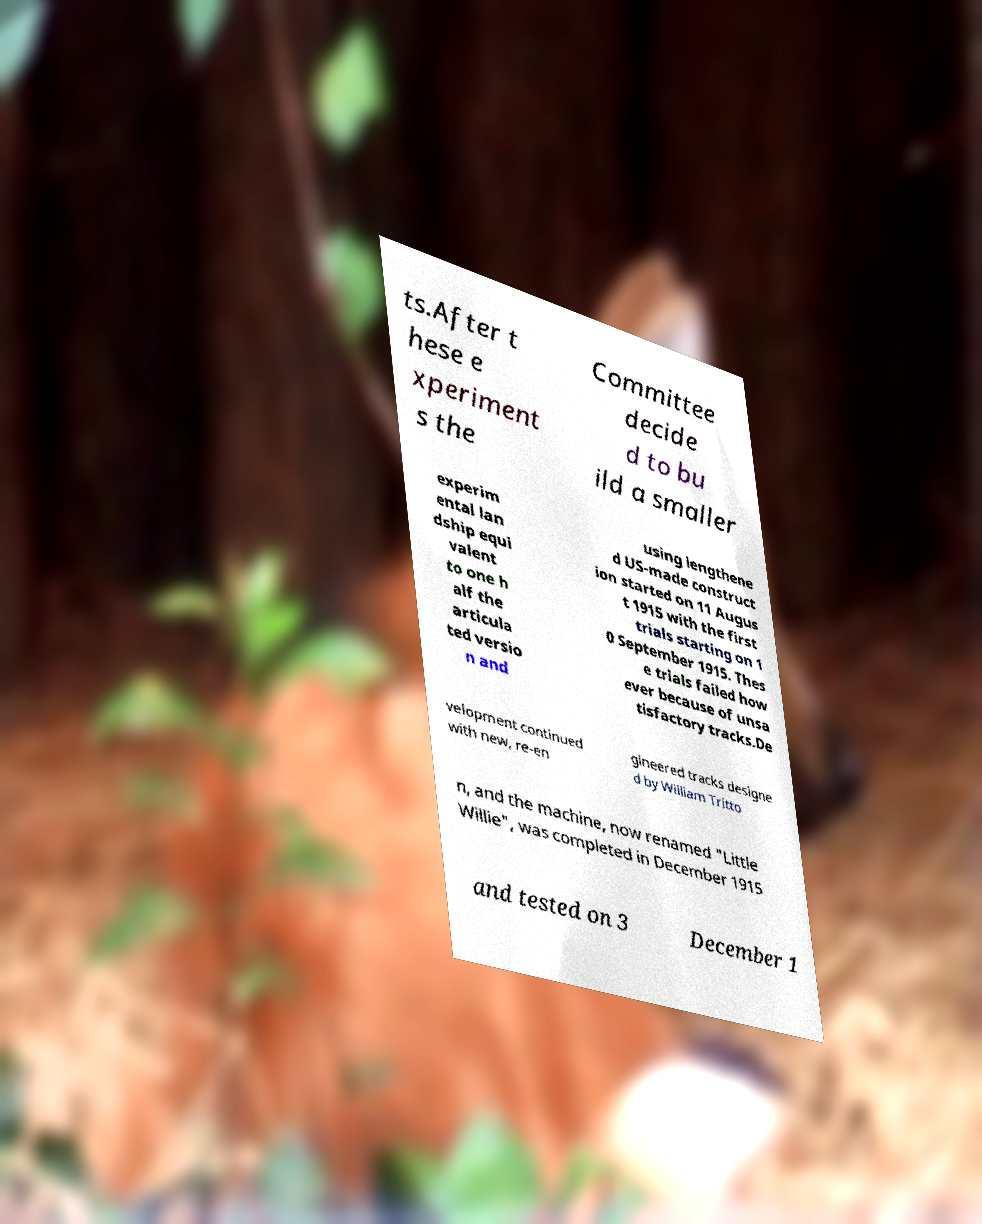What messages or text are displayed in this image? I need them in a readable, typed format. ts.After t hese e xperiment s the Committee decide d to bu ild a smaller experim ental lan dship equi valent to one h alf the articula ted versio n and using lengthene d US-made construct ion started on 11 Augus t 1915 with the first trials starting on 1 0 September 1915. Thes e trials failed how ever because of unsa tisfactory tracks.De velopment continued with new, re-en gineered tracks designe d by William Tritto n, and the machine, now renamed "Little Willie", was completed in December 1915 and tested on 3 December 1 